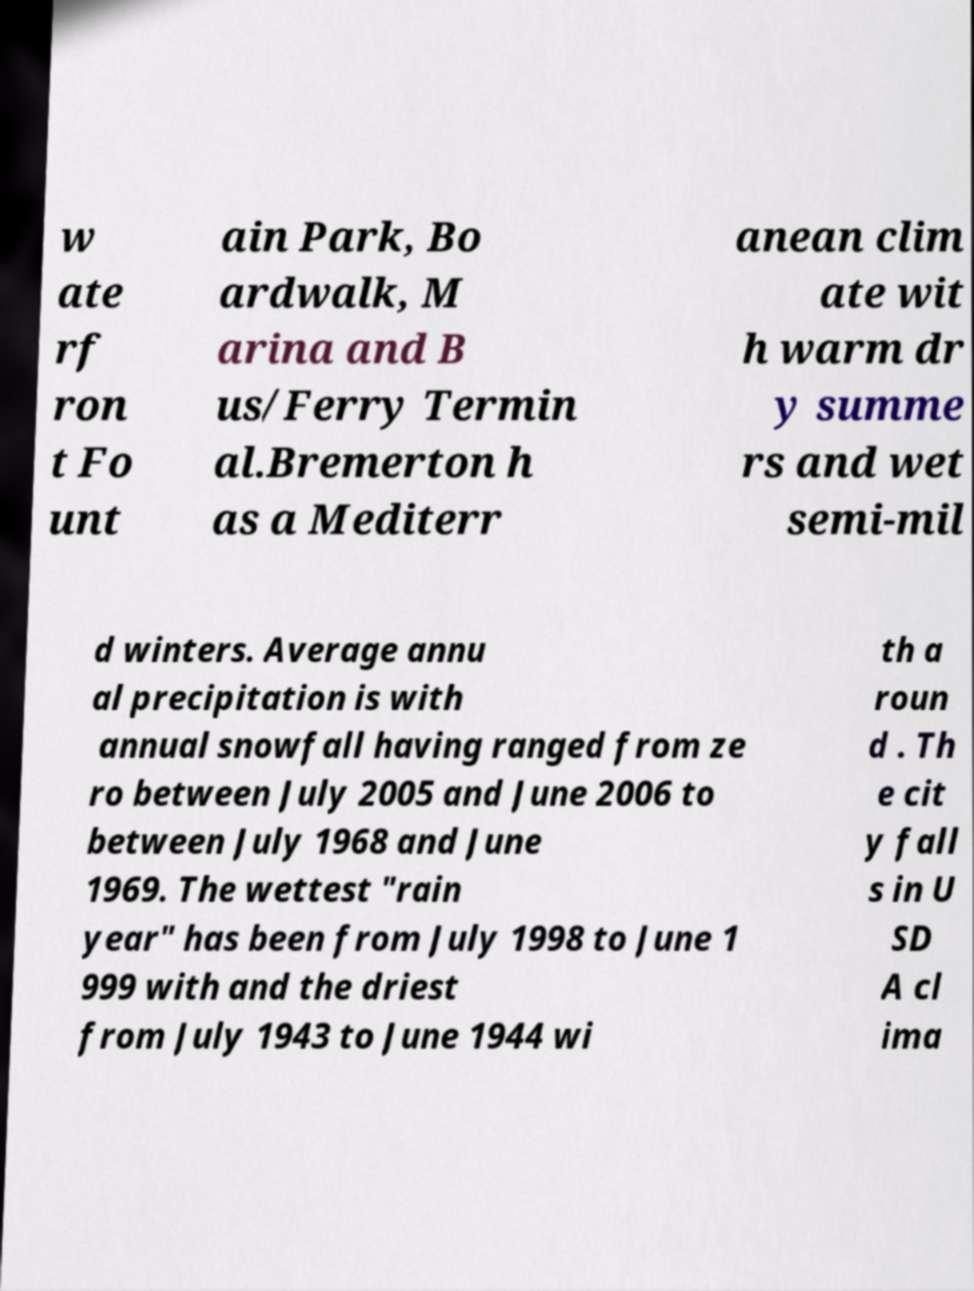Could you extract and type out the text from this image? w ate rf ron t Fo unt ain Park, Bo ardwalk, M arina and B us/Ferry Termin al.Bremerton h as a Mediterr anean clim ate wit h warm dr y summe rs and wet semi-mil d winters. Average annu al precipitation is with annual snowfall having ranged from ze ro between July 2005 and June 2006 to between July 1968 and June 1969. The wettest "rain year" has been from July 1998 to June 1 999 with and the driest from July 1943 to June 1944 wi th a roun d . Th e cit y fall s in U SD A cl ima 